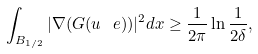Convert formula to latex. <formula><loc_0><loc_0><loc_500><loc_500>\int _ { B _ { 1 / 2 } } | \nabla ( G ( u _ { \ } e ) ) | ^ { 2 } d x \geq \frac { 1 } { 2 \pi } \ln \frac { 1 } { 2 \delta } ,</formula> 